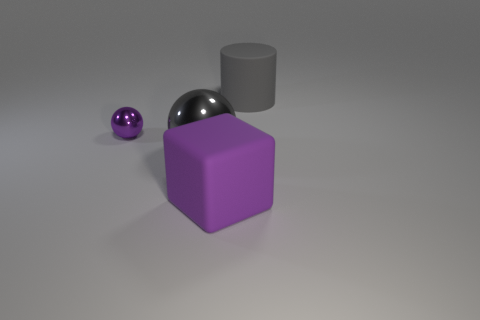Is there anything else that is the same size as the purple metallic object?
Your response must be concise. No. What number of balls are either large purple rubber things or rubber objects?
Make the answer very short. 0. What is the material of the big sphere that is the same color as the big matte cylinder?
Provide a short and direct response. Metal. Is the number of big gray metallic things that are behind the gray shiny thing less than the number of cylinders behind the gray rubber object?
Provide a succinct answer. No. How many things are objects that are in front of the big gray matte cylinder or small purple metallic objects?
Provide a short and direct response. 3. The metallic thing behind the gray thing to the left of the gray matte thing is what shape?
Offer a terse response. Sphere. Is there another purple ball of the same size as the purple metallic sphere?
Ensure brevity in your answer.  No. Is the number of red metallic cylinders greater than the number of balls?
Ensure brevity in your answer.  No. There is a gray object that is behind the big metal thing; is its size the same as the ball left of the big gray shiny thing?
Provide a succinct answer. No. How many objects are behind the big gray shiny thing and to the left of the gray cylinder?
Ensure brevity in your answer.  1. 